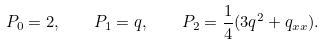<formula> <loc_0><loc_0><loc_500><loc_500>P _ { 0 } = 2 , \quad P _ { 1 } = q , \quad P _ { 2 } = \frac { 1 } { 4 } ( 3 { q } ^ { 2 } + q _ { x x } ) .</formula> 